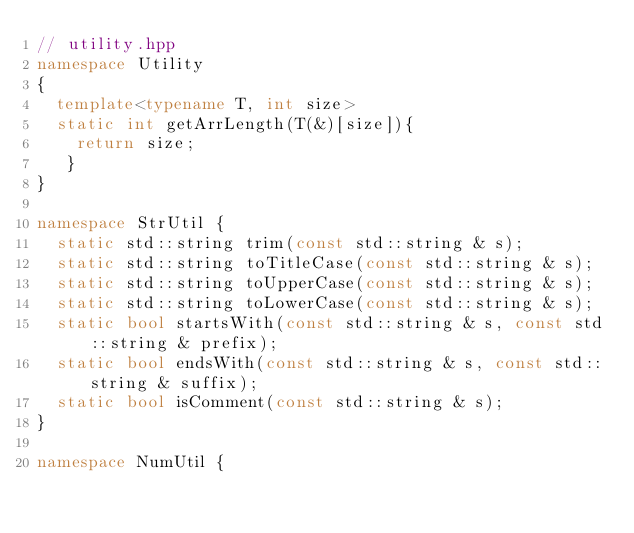Convert code to text. <code><loc_0><loc_0><loc_500><loc_500><_C++_>// utility.hpp
namespace Utility
{
  template<typename T, int size>
  static int getArrLength(T(&)[size]){
    return size;
   }
}

namespace StrUtil {
  static std::string trim(const std::string & s);
  static std::string toTitleCase(const std::string & s);
  static std::string toUpperCase(const std::string & s);
  static std::string toLowerCase(const std::string & s);
  static bool startsWith(const std::string & s, const std::string & prefix);
  static bool endsWith(const std::string & s, const std::string & suffix);
  static bool isComment(const std::string & s);
}

namespace NumUtil {
</code> 